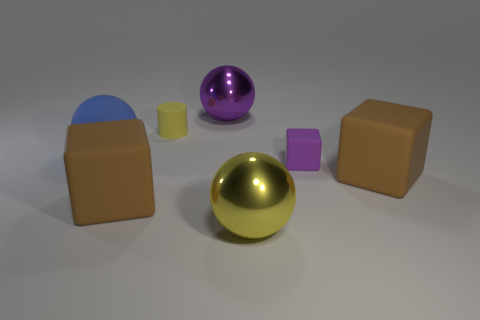How does the light source in the image affect the appearance of the objects? The light source in the image is positioned to highlight the different textures and reflective properties of the objects. It creates soft shadows and defines the contours of the shapes. The matte objects reflect the light diffusely, giving a soft appearance, while the metallic spheres have strong highlights and reflections that emphasize their glossy texture. 